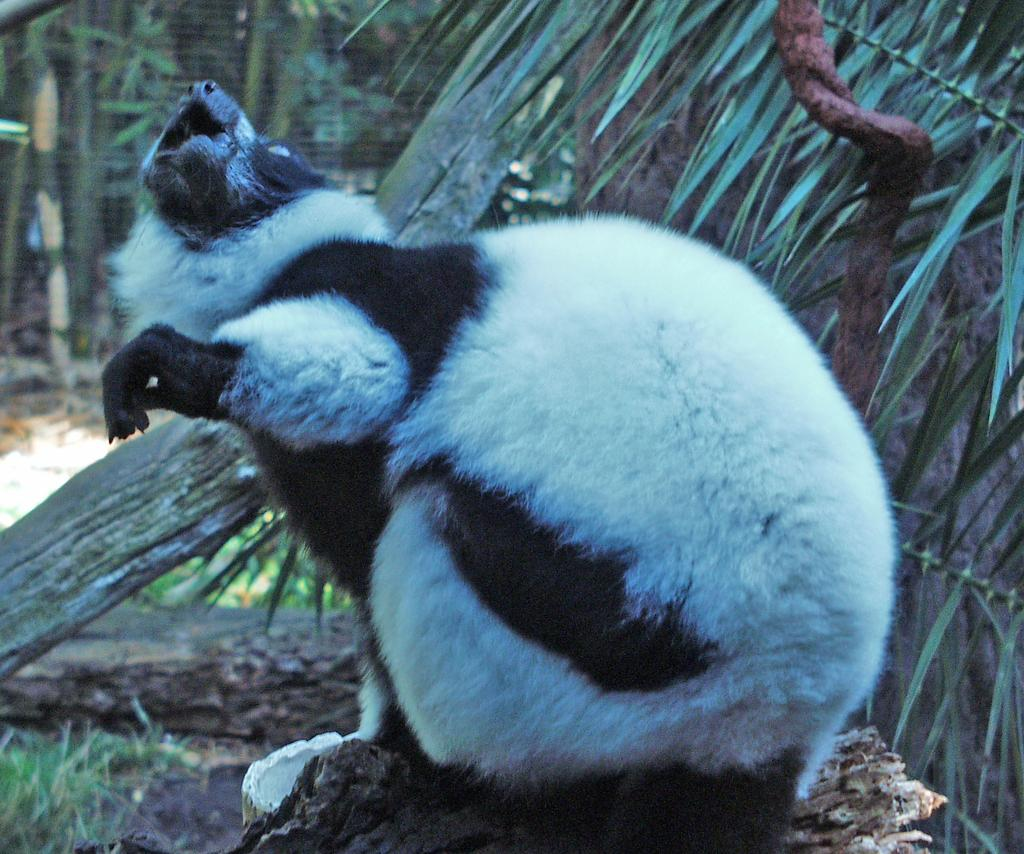What type of animal is in the image? The animal in the image is black and white in color. Where is the animal located in the image? The animal is in the middle of the image. What can be seen in the background of the image? There are trees in the background of the image. What type of industry is depicted in the image? There is no industry depicted in the image; it features an animal in the middle of the image with trees in the background. 